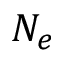Convert formula to latex. <formula><loc_0><loc_0><loc_500><loc_500>N _ { e }</formula> 